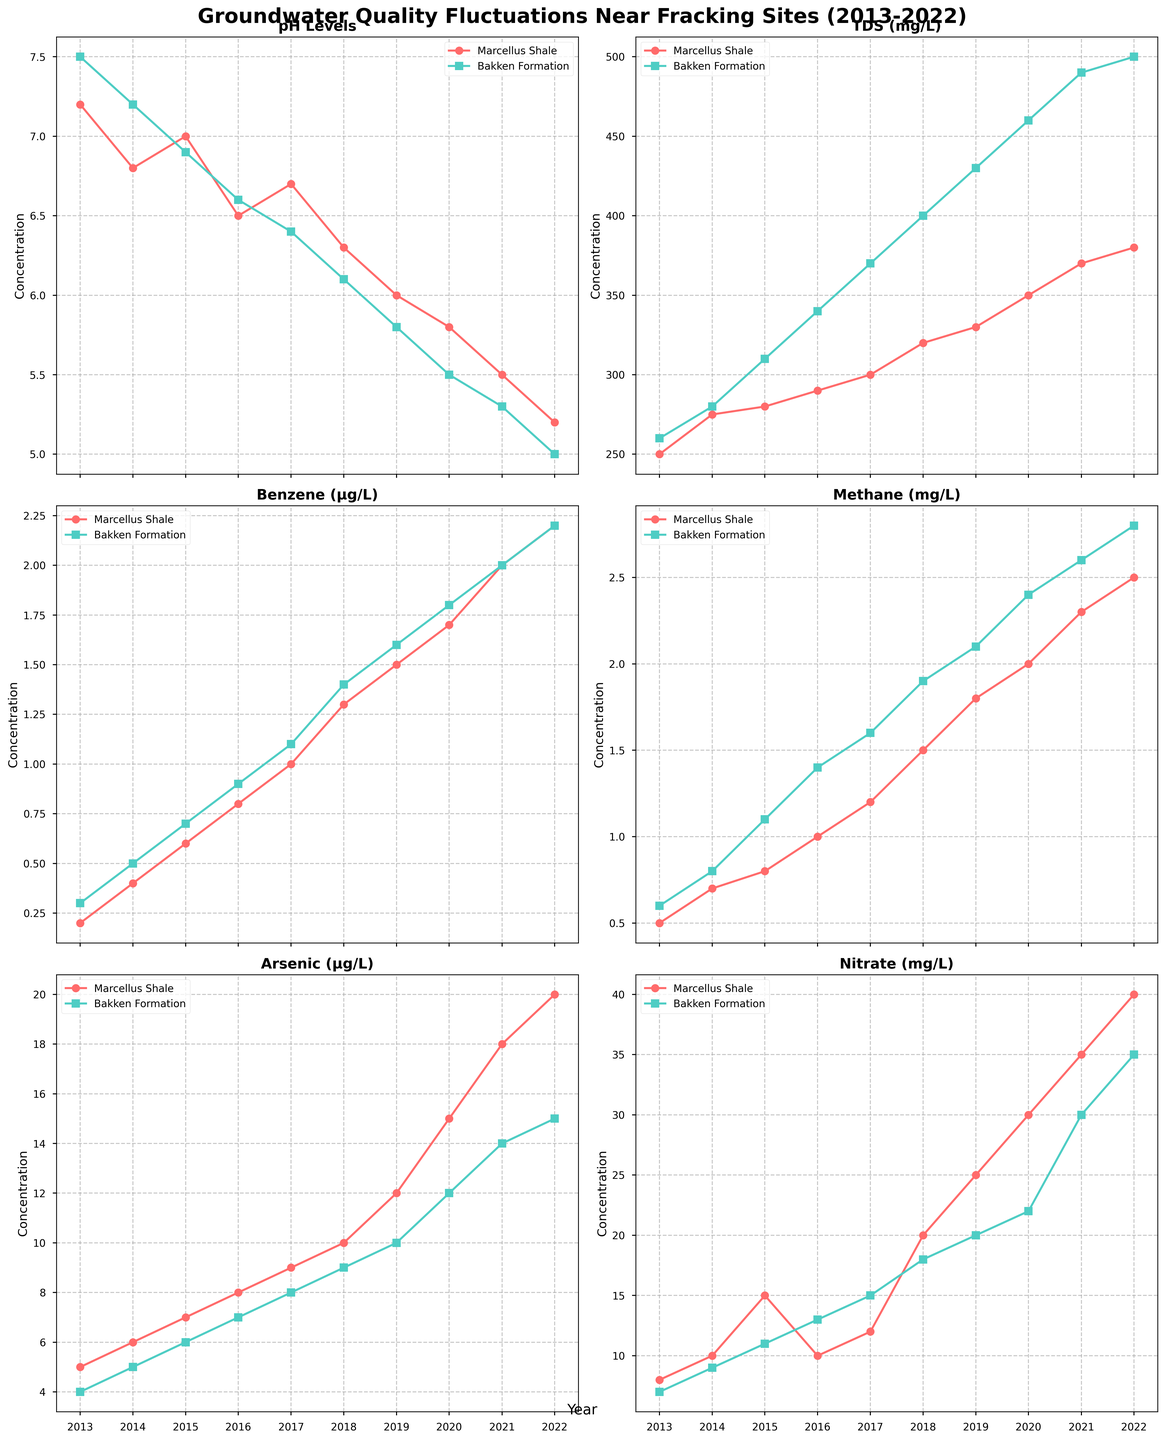What is the title of the figure? The title is typically placed at the top of the figure and usually summarizes the main topic or findings. In this case, it would read the main purpose of the plot.
Answer: Groundwater Quality Fluctuations Near Fracking Sites (2013-2022) How do the pH levels in Marcellus Shale change over the decade? The pH level trend in the Marcellus Shale data can be observed in the plot. It starts relatively neutral in 2013 and decreases consistently towards more acidic levels in 2022.
Answer: They decrease from 7.2 to 5.2 Which location shows a greater increase in TDS (Total Dissolved Solids) over the decade? Compare the starting and ending values of TDS for both Marcellus Shale and Bakken Formation over the decade. Calculate the change for each.
Answer: Bakken Formation, from 260 mg/L to 500 mg/L Which site has higher Benzene levels in 2022? Look at the Benzene (µg/L) parameter plot and check the values for the year 2022 for both locations. Compare the values.
Answer: Bakken Formation, with 2.2 µg/L Between Methane and Arsenic, which contaminant shows a more significant increase in the Bakken Formation? Look at both the Methane (mg/L) and Arsenic (µg/L) plots for Bakken Formation. Calculate the differences from 2013 to 2022 for each and compare the amount of increase.
Answer: Arsenic, increased from 4 µg/L to 15 µg/L What was the nitrate level in Marcellus Shale in 2017? Locate the Nitrate (mg/L) plot and find the specific data point for Marcellus Shale in the year 2017.
Answer: 12 mg/L What is the trend observed in Methane levels in Marcellus Shale over the decade? Locate the Methane (mg/L) plot for Marcellus Shale. Observe the trend from 2013 to 2022. The line shows a steady increase.
Answer: Increasing Which parameter in Bakken Formation reached the highest value in the decade? Compare the maximum values of all the parameters (pH Levels, TDS, Benzene, Methane, Arsenic, Nitrate) in the Bakken Formation plots. Identify which parameter has the highest peak.
Answer: TDS, 500 mg/L Compare the pH levels in both locations for the year 2019. Which one is closer to neutral (7.0)? Find the pH levels for both locations in the year 2019. Compare their values to see which is closer to 7.0.
Answer: Marcellus Shale, with a pH of 6.0 Calculate the average increase in Nitrate levels in Bakken Formation over the first five years (2013-2017). Identify the Nitrate values for Bakken Formation from 2013 to 2017. Calculate the differences for consecutive years and then average these increases. 
( (9-7) + (11-9) + (13-11) + (15-13) ) / 4 = (2 + 2 + 2 + 2) / 4 = 2 mg/L per year.
Answer: 2 mg/L per year 